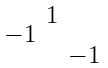<formula> <loc_0><loc_0><loc_500><loc_500>\begin{smallmatrix} & 1 & \\ - 1 & & \\ & & - 1 \end{smallmatrix}</formula> 